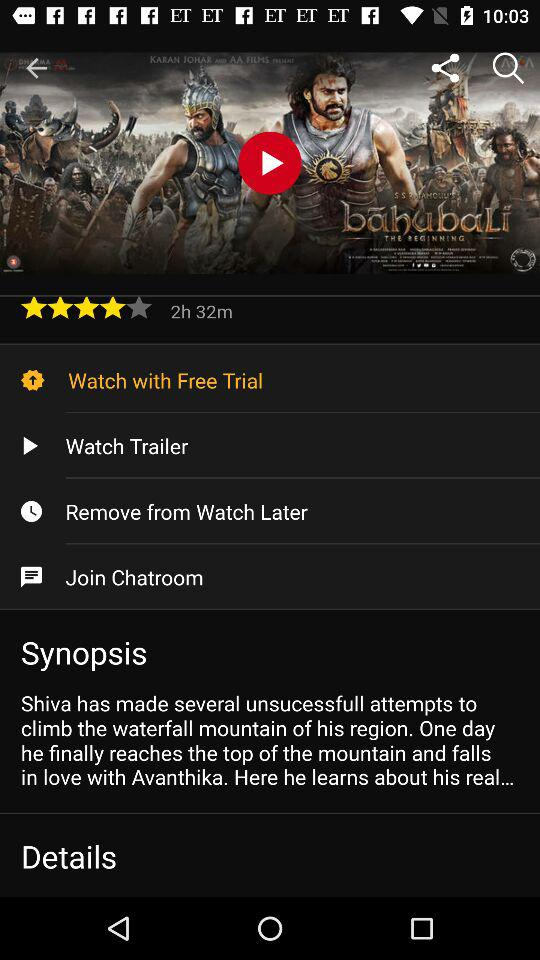What is the title of the movie? The title of the movie is "bãhubaLi". 